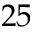<formula> <loc_0><loc_0><loc_500><loc_500>2 5</formula> 